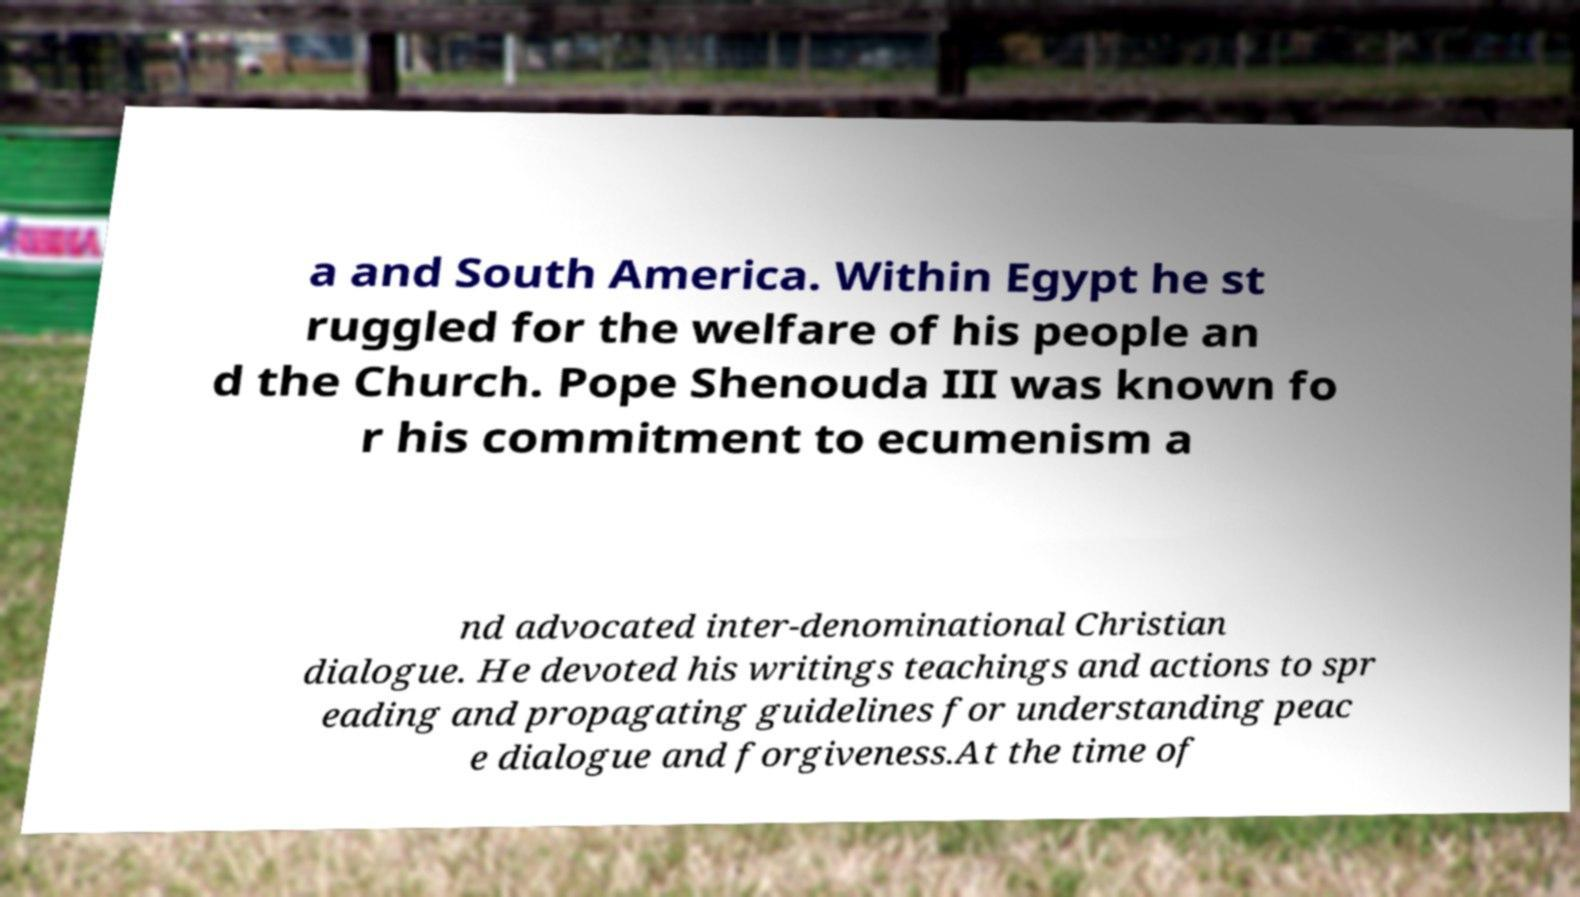There's text embedded in this image that I need extracted. Can you transcribe it verbatim? a and South America. Within Egypt he st ruggled for the welfare of his people an d the Church. Pope Shenouda III was known fo r his commitment to ecumenism a nd advocated inter-denominational Christian dialogue. He devoted his writings teachings and actions to spr eading and propagating guidelines for understanding peac e dialogue and forgiveness.At the time of 